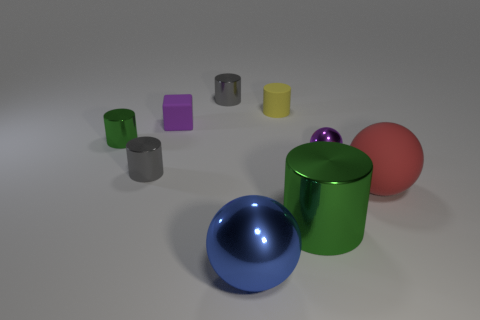There is a small purple metallic object; what shape is it?
Your answer should be very brief. Sphere. Are there more objects that are in front of the red sphere than large cylinders that are to the left of the large metallic cylinder?
Your answer should be very brief. Yes. There is a yellow rubber thing that is behind the red matte sphere; is its shape the same as the green shiny thing that is behind the big green thing?
Provide a succinct answer. Yes. How many other objects are the same size as the purple matte cube?
Offer a very short reply. 5. The blue ball has what size?
Offer a terse response. Large. Are the tiny cylinder that is in front of the small green cylinder and the blue thing made of the same material?
Offer a very short reply. Yes. What is the color of the small rubber object that is the same shape as the big green metal thing?
Your answer should be very brief. Yellow. Do the matte thing left of the blue ball and the tiny shiny sphere have the same color?
Ensure brevity in your answer.  Yes. There is a rubber cylinder; are there any blue spheres in front of it?
Offer a terse response. Yes. There is a metallic object that is both in front of the red matte sphere and left of the small rubber cylinder; what color is it?
Provide a short and direct response. Blue. 